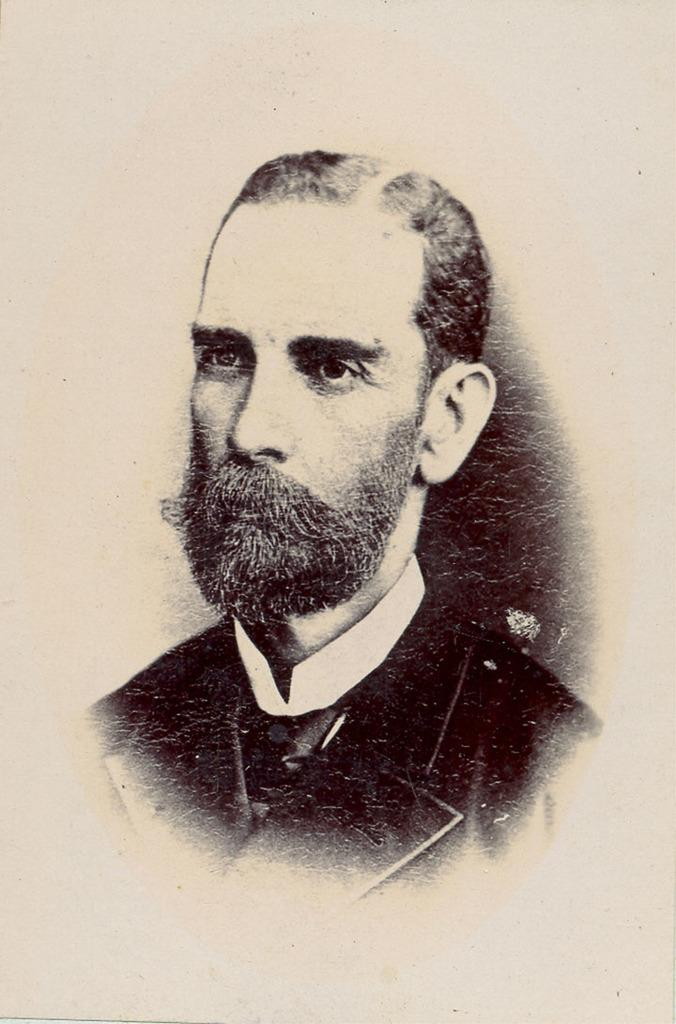What is the main subject of the image? There is a picture of a person in the image. What type of milk is being used by the cook in the harbor in the image? There is no cook, milk, or harbor present in the image; it only features a picture of a person. 